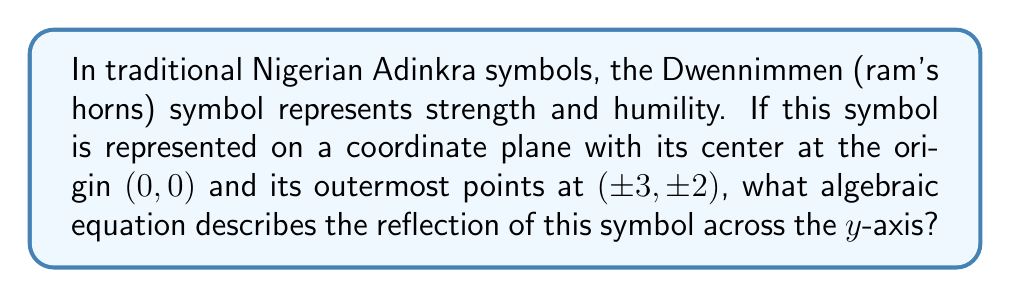What is the answer to this math problem? To solve this problem, let's follow these steps:

1. First, we need to understand what reflection across the y-axis means algebraically. When a point (x, y) is reflected across the y-axis, its new coordinates become (-x, y).

2. The original symbol has its outermost points at (±3, ±2). This means the points (3, 2), (3, -2), (-3, 2), and (-3, -2) are on the symbol.

3. When we reflect these points across the y-axis:
   (3, 2) becomes (-3, 2)
   (3, -2) becomes (-3, -2)
   (-3, 2) becomes (3, 2)
   (-3, -2) becomes (3, -2)

4. We can see that the reflection essentially swaps the x-coordinates while keeping the y-coordinates the same.

5. If we assume the original symbol is described by an equation $f(x, y) = 0$, then the reflected symbol would be described by $f(-x, y) = 0$.

6. For example, if part of the original symbol was described by the equation $x^2 + y^2 = 9$, the reflected part would be described by $(-x)^2 + y^2 = 9$, which simplifies to the same equation $x^2 + y^2 = 9$.

7. This means that for any point (x, y) on the original symbol, the point (-x, y) will be on the reflected symbol.
Answer: $f(-x, y) = 0$, where $f(x, y) = 0$ is the equation of the original symbol 